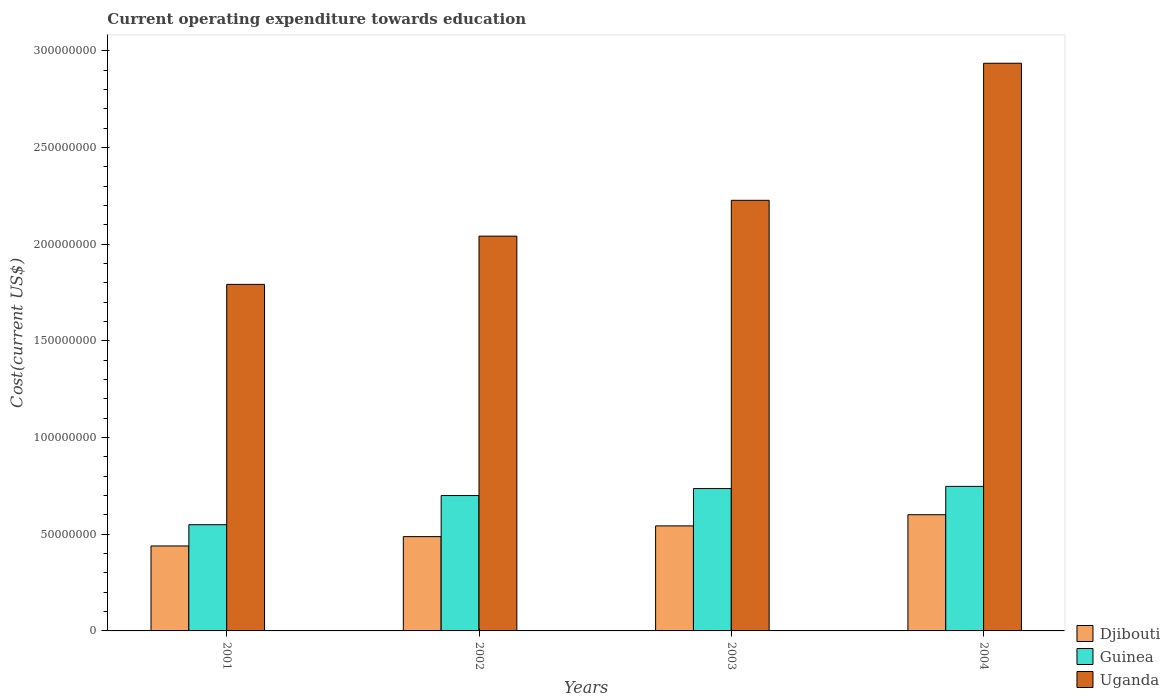How many different coloured bars are there?
Your answer should be compact. 3. How many groups of bars are there?
Ensure brevity in your answer.  4. Are the number of bars per tick equal to the number of legend labels?
Make the answer very short. Yes. How many bars are there on the 2nd tick from the left?
Your answer should be very brief. 3. What is the label of the 3rd group of bars from the left?
Keep it short and to the point. 2003. In how many cases, is the number of bars for a given year not equal to the number of legend labels?
Provide a succinct answer. 0. What is the expenditure towards education in Djibouti in 2003?
Your answer should be very brief. 5.43e+07. Across all years, what is the maximum expenditure towards education in Uganda?
Offer a very short reply. 2.94e+08. Across all years, what is the minimum expenditure towards education in Djibouti?
Provide a succinct answer. 4.39e+07. In which year was the expenditure towards education in Guinea minimum?
Your answer should be compact. 2001. What is the total expenditure towards education in Djibouti in the graph?
Provide a succinct answer. 2.07e+08. What is the difference between the expenditure towards education in Djibouti in 2001 and that in 2004?
Offer a very short reply. -1.62e+07. What is the difference between the expenditure towards education in Guinea in 2002 and the expenditure towards education in Uganda in 2004?
Offer a terse response. -2.24e+08. What is the average expenditure towards education in Djibouti per year?
Ensure brevity in your answer.  5.18e+07. In the year 2001, what is the difference between the expenditure towards education in Uganda and expenditure towards education in Guinea?
Provide a succinct answer. 1.24e+08. In how many years, is the expenditure towards education in Djibouti greater than 160000000 US$?
Offer a terse response. 0. What is the ratio of the expenditure towards education in Djibouti in 2001 to that in 2002?
Your answer should be very brief. 0.9. What is the difference between the highest and the second highest expenditure towards education in Djibouti?
Give a very brief answer. 5.78e+06. What is the difference between the highest and the lowest expenditure towards education in Guinea?
Offer a very short reply. 1.98e+07. Is the sum of the expenditure towards education in Uganda in 2001 and 2003 greater than the maximum expenditure towards education in Djibouti across all years?
Keep it short and to the point. Yes. What does the 2nd bar from the left in 2004 represents?
Give a very brief answer. Guinea. What does the 1st bar from the right in 2001 represents?
Provide a succinct answer. Uganda. Are all the bars in the graph horizontal?
Your answer should be very brief. No. How many years are there in the graph?
Keep it short and to the point. 4. What is the difference between two consecutive major ticks on the Y-axis?
Offer a very short reply. 5.00e+07. Are the values on the major ticks of Y-axis written in scientific E-notation?
Offer a very short reply. No. Does the graph contain any zero values?
Keep it short and to the point. No. Does the graph contain grids?
Provide a succinct answer. No. How many legend labels are there?
Provide a succinct answer. 3. How are the legend labels stacked?
Make the answer very short. Vertical. What is the title of the graph?
Your answer should be very brief. Current operating expenditure towards education. Does "Swaziland" appear as one of the legend labels in the graph?
Keep it short and to the point. No. What is the label or title of the X-axis?
Give a very brief answer. Years. What is the label or title of the Y-axis?
Ensure brevity in your answer.  Cost(current US$). What is the Cost(current US$) in Djibouti in 2001?
Offer a terse response. 4.39e+07. What is the Cost(current US$) in Guinea in 2001?
Your answer should be very brief. 5.49e+07. What is the Cost(current US$) in Uganda in 2001?
Your response must be concise. 1.79e+08. What is the Cost(current US$) of Djibouti in 2002?
Your answer should be very brief. 4.88e+07. What is the Cost(current US$) of Guinea in 2002?
Provide a short and direct response. 7.00e+07. What is the Cost(current US$) in Uganda in 2002?
Your answer should be compact. 2.04e+08. What is the Cost(current US$) of Djibouti in 2003?
Your answer should be compact. 5.43e+07. What is the Cost(current US$) in Guinea in 2003?
Offer a terse response. 7.36e+07. What is the Cost(current US$) of Uganda in 2003?
Keep it short and to the point. 2.23e+08. What is the Cost(current US$) in Djibouti in 2004?
Offer a terse response. 6.01e+07. What is the Cost(current US$) of Guinea in 2004?
Make the answer very short. 7.48e+07. What is the Cost(current US$) of Uganda in 2004?
Offer a terse response. 2.94e+08. Across all years, what is the maximum Cost(current US$) in Djibouti?
Your answer should be compact. 6.01e+07. Across all years, what is the maximum Cost(current US$) of Guinea?
Give a very brief answer. 7.48e+07. Across all years, what is the maximum Cost(current US$) of Uganda?
Your answer should be very brief. 2.94e+08. Across all years, what is the minimum Cost(current US$) in Djibouti?
Give a very brief answer. 4.39e+07. Across all years, what is the minimum Cost(current US$) in Guinea?
Provide a succinct answer. 5.49e+07. Across all years, what is the minimum Cost(current US$) in Uganda?
Make the answer very short. 1.79e+08. What is the total Cost(current US$) of Djibouti in the graph?
Keep it short and to the point. 2.07e+08. What is the total Cost(current US$) of Guinea in the graph?
Your answer should be very brief. 2.73e+08. What is the total Cost(current US$) in Uganda in the graph?
Give a very brief answer. 9.00e+08. What is the difference between the Cost(current US$) of Djibouti in 2001 and that in 2002?
Keep it short and to the point. -4.83e+06. What is the difference between the Cost(current US$) in Guinea in 2001 and that in 2002?
Your answer should be very brief. -1.51e+07. What is the difference between the Cost(current US$) of Uganda in 2001 and that in 2002?
Your response must be concise. -2.49e+07. What is the difference between the Cost(current US$) of Djibouti in 2001 and that in 2003?
Make the answer very short. -1.04e+07. What is the difference between the Cost(current US$) in Guinea in 2001 and that in 2003?
Your answer should be very brief. -1.87e+07. What is the difference between the Cost(current US$) of Uganda in 2001 and that in 2003?
Your answer should be compact. -4.35e+07. What is the difference between the Cost(current US$) of Djibouti in 2001 and that in 2004?
Give a very brief answer. -1.62e+07. What is the difference between the Cost(current US$) in Guinea in 2001 and that in 2004?
Make the answer very short. -1.98e+07. What is the difference between the Cost(current US$) in Uganda in 2001 and that in 2004?
Make the answer very short. -1.14e+08. What is the difference between the Cost(current US$) in Djibouti in 2002 and that in 2003?
Offer a terse response. -5.55e+06. What is the difference between the Cost(current US$) of Guinea in 2002 and that in 2003?
Offer a terse response. -3.61e+06. What is the difference between the Cost(current US$) in Uganda in 2002 and that in 2003?
Offer a terse response. -1.85e+07. What is the difference between the Cost(current US$) of Djibouti in 2002 and that in 2004?
Your answer should be compact. -1.13e+07. What is the difference between the Cost(current US$) in Guinea in 2002 and that in 2004?
Make the answer very short. -4.74e+06. What is the difference between the Cost(current US$) in Uganda in 2002 and that in 2004?
Make the answer very short. -8.94e+07. What is the difference between the Cost(current US$) of Djibouti in 2003 and that in 2004?
Offer a very short reply. -5.78e+06. What is the difference between the Cost(current US$) of Guinea in 2003 and that in 2004?
Provide a succinct answer. -1.13e+06. What is the difference between the Cost(current US$) of Uganda in 2003 and that in 2004?
Your answer should be compact. -7.09e+07. What is the difference between the Cost(current US$) of Djibouti in 2001 and the Cost(current US$) of Guinea in 2002?
Your answer should be very brief. -2.61e+07. What is the difference between the Cost(current US$) of Djibouti in 2001 and the Cost(current US$) of Uganda in 2002?
Provide a short and direct response. -1.60e+08. What is the difference between the Cost(current US$) of Guinea in 2001 and the Cost(current US$) of Uganda in 2002?
Your answer should be very brief. -1.49e+08. What is the difference between the Cost(current US$) of Djibouti in 2001 and the Cost(current US$) of Guinea in 2003?
Your answer should be compact. -2.97e+07. What is the difference between the Cost(current US$) of Djibouti in 2001 and the Cost(current US$) of Uganda in 2003?
Your answer should be compact. -1.79e+08. What is the difference between the Cost(current US$) of Guinea in 2001 and the Cost(current US$) of Uganda in 2003?
Give a very brief answer. -1.68e+08. What is the difference between the Cost(current US$) in Djibouti in 2001 and the Cost(current US$) in Guinea in 2004?
Give a very brief answer. -3.08e+07. What is the difference between the Cost(current US$) in Djibouti in 2001 and the Cost(current US$) in Uganda in 2004?
Provide a succinct answer. -2.50e+08. What is the difference between the Cost(current US$) of Guinea in 2001 and the Cost(current US$) of Uganda in 2004?
Offer a terse response. -2.39e+08. What is the difference between the Cost(current US$) in Djibouti in 2002 and the Cost(current US$) in Guinea in 2003?
Give a very brief answer. -2.49e+07. What is the difference between the Cost(current US$) in Djibouti in 2002 and the Cost(current US$) in Uganda in 2003?
Ensure brevity in your answer.  -1.74e+08. What is the difference between the Cost(current US$) in Guinea in 2002 and the Cost(current US$) in Uganda in 2003?
Provide a short and direct response. -1.53e+08. What is the difference between the Cost(current US$) in Djibouti in 2002 and the Cost(current US$) in Guinea in 2004?
Give a very brief answer. -2.60e+07. What is the difference between the Cost(current US$) of Djibouti in 2002 and the Cost(current US$) of Uganda in 2004?
Give a very brief answer. -2.45e+08. What is the difference between the Cost(current US$) of Guinea in 2002 and the Cost(current US$) of Uganda in 2004?
Your answer should be compact. -2.24e+08. What is the difference between the Cost(current US$) of Djibouti in 2003 and the Cost(current US$) of Guinea in 2004?
Offer a very short reply. -2.04e+07. What is the difference between the Cost(current US$) in Djibouti in 2003 and the Cost(current US$) in Uganda in 2004?
Your answer should be very brief. -2.39e+08. What is the difference between the Cost(current US$) of Guinea in 2003 and the Cost(current US$) of Uganda in 2004?
Your response must be concise. -2.20e+08. What is the average Cost(current US$) in Djibouti per year?
Keep it short and to the point. 5.18e+07. What is the average Cost(current US$) of Guinea per year?
Your answer should be compact. 6.83e+07. What is the average Cost(current US$) in Uganda per year?
Provide a short and direct response. 2.25e+08. In the year 2001, what is the difference between the Cost(current US$) of Djibouti and Cost(current US$) of Guinea?
Offer a very short reply. -1.10e+07. In the year 2001, what is the difference between the Cost(current US$) of Djibouti and Cost(current US$) of Uganda?
Your answer should be very brief. -1.35e+08. In the year 2001, what is the difference between the Cost(current US$) of Guinea and Cost(current US$) of Uganda?
Your answer should be very brief. -1.24e+08. In the year 2002, what is the difference between the Cost(current US$) in Djibouti and Cost(current US$) in Guinea?
Provide a succinct answer. -2.12e+07. In the year 2002, what is the difference between the Cost(current US$) of Djibouti and Cost(current US$) of Uganda?
Provide a succinct answer. -1.55e+08. In the year 2002, what is the difference between the Cost(current US$) in Guinea and Cost(current US$) in Uganda?
Provide a succinct answer. -1.34e+08. In the year 2003, what is the difference between the Cost(current US$) in Djibouti and Cost(current US$) in Guinea?
Provide a succinct answer. -1.93e+07. In the year 2003, what is the difference between the Cost(current US$) of Djibouti and Cost(current US$) of Uganda?
Your response must be concise. -1.68e+08. In the year 2003, what is the difference between the Cost(current US$) in Guinea and Cost(current US$) in Uganda?
Offer a very short reply. -1.49e+08. In the year 2004, what is the difference between the Cost(current US$) of Djibouti and Cost(current US$) of Guinea?
Give a very brief answer. -1.47e+07. In the year 2004, what is the difference between the Cost(current US$) of Djibouti and Cost(current US$) of Uganda?
Provide a succinct answer. -2.33e+08. In the year 2004, what is the difference between the Cost(current US$) of Guinea and Cost(current US$) of Uganda?
Your answer should be very brief. -2.19e+08. What is the ratio of the Cost(current US$) in Djibouti in 2001 to that in 2002?
Your answer should be very brief. 0.9. What is the ratio of the Cost(current US$) of Guinea in 2001 to that in 2002?
Offer a terse response. 0.78. What is the ratio of the Cost(current US$) of Uganda in 2001 to that in 2002?
Provide a short and direct response. 0.88. What is the ratio of the Cost(current US$) in Djibouti in 2001 to that in 2003?
Keep it short and to the point. 0.81. What is the ratio of the Cost(current US$) of Guinea in 2001 to that in 2003?
Your answer should be compact. 0.75. What is the ratio of the Cost(current US$) of Uganda in 2001 to that in 2003?
Provide a succinct answer. 0.8. What is the ratio of the Cost(current US$) in Djibouti in 2001 to that in 2004?
Your answer should be very brief. 0.73. What is the ratio of the Cost(current US$) in Guinea in 2001 to that in 2004?
Your answer should be compact. 0.73. What is the ratio of the Cost(current US$) in Uganda in 2001 to that in 2004?
Provide a succinct answer. 0.61. What is the ratio of the Cost(current US$) of Djibouti in 2002 to that in 2003?
Keep it short and to the point. 0.9. What is the ratio of the Cost(current US$) of Guinea in 2002 to that in 2003?
Ensure brevity in your answer.  0.95. What is the ratio of the Cost(current US$) of Uganda in 2002 to that in 2003?
Offer a terse response. 0.92. What is the ratio of the Cost(current US$) in Djibouti in 2002 to that in 2004?
Give a very brief answer. 0.81. What is the ratio of the Cost(current US$) in Guinea in 2002 to that in 2004?
Ensure brevity in your answer.  0.94. What is the ratio of the Cost(current US$) of Uganda in 2002 to that in 2004?
Provide a succinct answer. 0.7. What is the ratio of the Cost(current US$) in Djibouti in 2003 to that in 2004?
Offer a terse response. 0.9. What is the ratio of the Cost(current US$) in Guinea in 2003 to that in 2004?
Offer a terse response. 0.98. What is the ratio of the Cost(current US$) of Uganda in 2003 to that in 2004?
Give a very brief answer. 0.76. What is the difference between the highest and the second highest Cost(current US$) of Djibouti?
Give a very brief answer. 5.78e+06. What is the difference between the highest and the second highest Cost(current US$) of Guinea?
Make the answer very short. 1.13e+06. What is the difference between the highest and the second highest Cost(current US$) of Uganda?
Provide a succinct answer. 7.09e+07. What is the difference between the highest and the lowest Cost(current US$) in Djibouti?
Ensure brevity in your answer.  1.62e+07. What is the difference between the highest and the lowest Cost(current US$) of Guinea?
Offer a very short reply. 1.98e+07. What is the difference between the highest and the lowest Cost(current US$) of Uganda?
Your response must be concise. 1.14e+08. 